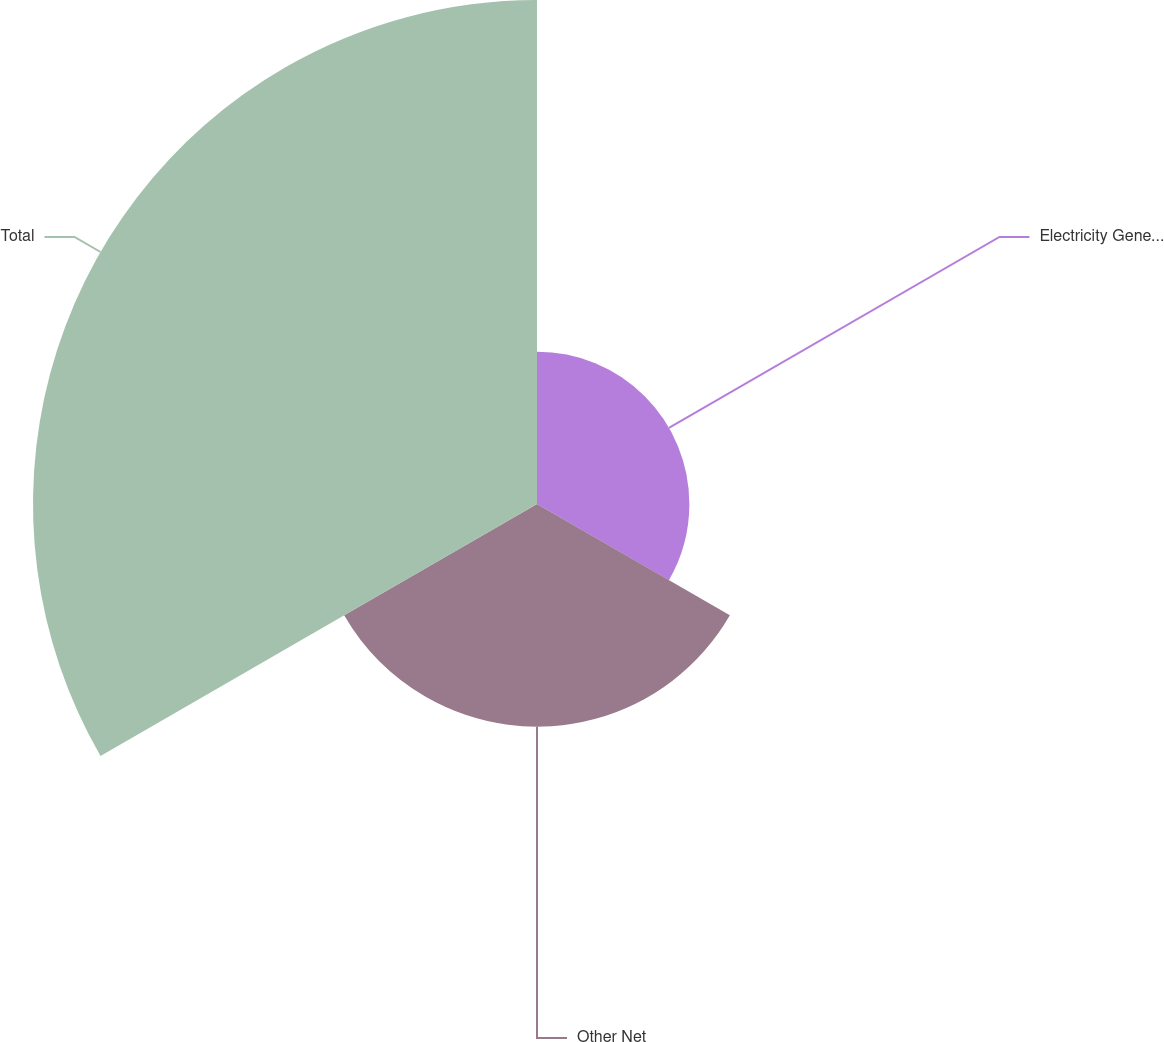Convert chart. <chart><loc_0><loc_0><loc_500><loc_500><pie_chart><fcel>Electricity Generation Expense<fcel>Other Net<fcel>Total<nl><fcel>17.33%<fcel>25.33%<fcel>57.33%<nl></chart> 